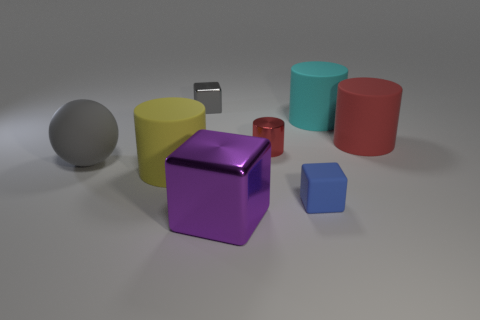Subtract all blue balls. Subtract all green cylinders. How many balls are left? 1 Subtract all cyan blocks. How many red spheres are left? 0 Add 7 purples. How many blues exist? 0 Subtract all cyan metal cylinders. Subtract all small blue cubes. How many objects are left? 7 Add 8 large purple metallic cubes. How many large purple metallic cubes are left? 9 Add 4 tiny cylinders. How many tiny cylinders exist? 5 Add 1 cyan matte objects. How many objects exist? 9 Subtract all purple cubes. How many cubes are left? 2 Subtract all cyan cylinders. How many cylinders are left? 3 Subtract 1 yellow cylinders. How many objects are left? 7 